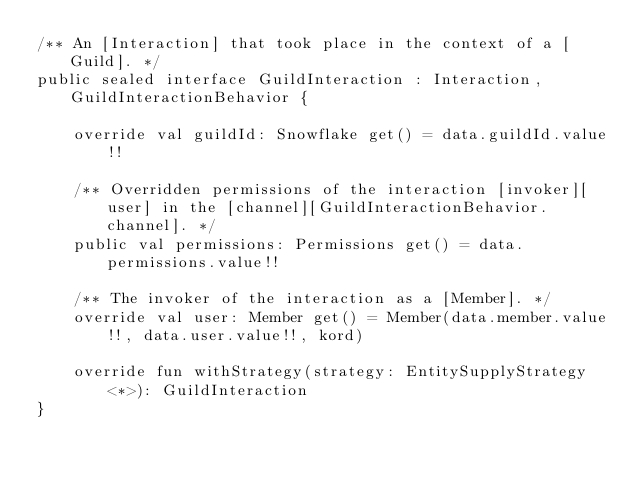Convert code to text. <code><loc_0><loc_0><loc_500><loc_500><_Kotlin_>/** An [Interaction] that took place in the context of a [Guild]. */
public sealed interface GuildInteraction : Interaction, GuildInteractionBehavior {

    override val guildId: Snowflake get() = data.guildId.value!!

    /** Overridden permissions of the interaction [invoker][user] in the [channel][GuildInteractionBehavior.channel]. */
    public val permissions: Permissions get() = data.permissions.value!!

    /** The invoker of the interaction as a [Member]. */
    override val user: Member get() = Member(data.member.value!!, data.user.value!!, kord)

    override fun withStrategy(strategy: EntitySupplyStrategy<*>): GuildInteraction
}
</code> 